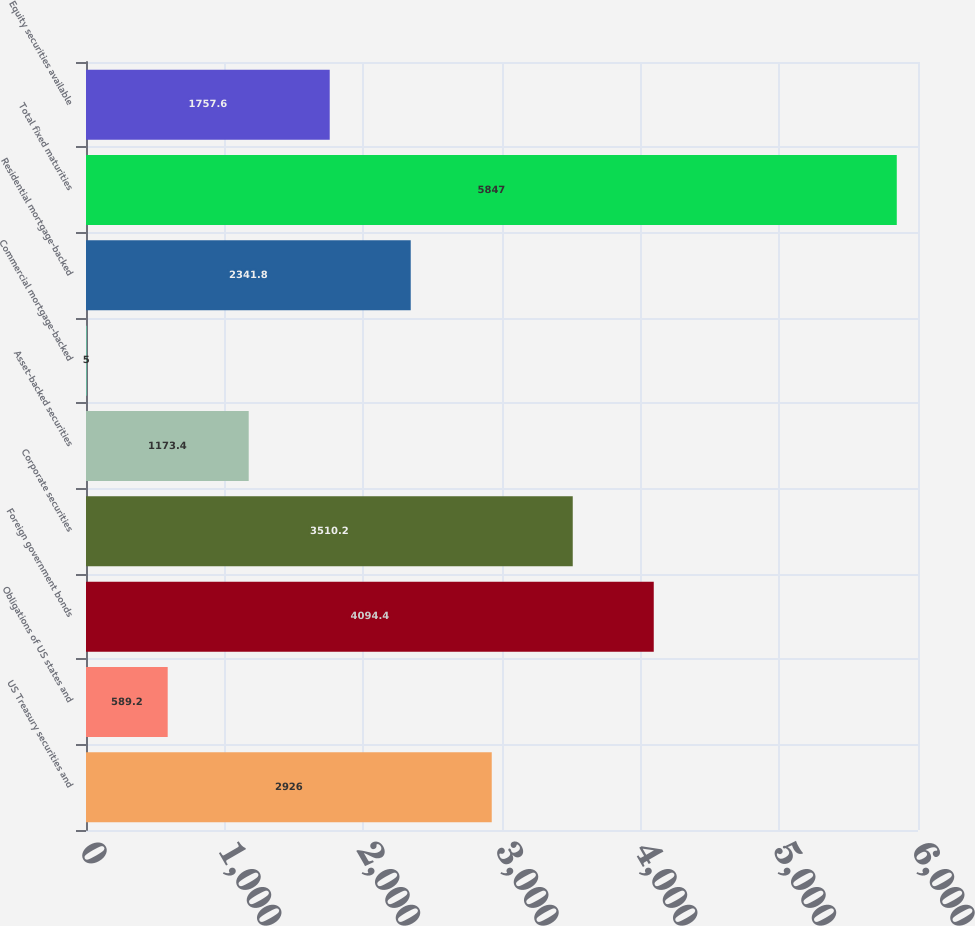Convert chart. <chart><loc_0><loc_0><loc_500><loc_500><bar_chart><fcel>US Treasury securities and<fcel>Obligations of US states and<fcel>Foreign government bonds<fcel>Corporate securities<fcel>Asset-backed securities<fcel>Commercial mortgage-backed<fcel>Residential mortgage-backed<fcel>Total fixed maturities<fcel>Equity securities available<nl><fcel>2926<fcel>589.2<fcel>4094.4<fcel>3510.2<fcel>1173.4<fcel>5<fcel>2341.8<fcel>5847<fcel>1757.6<nl></chart> 